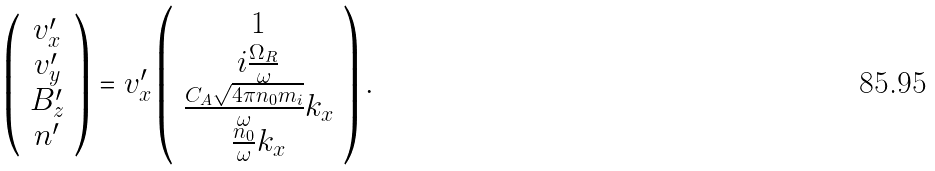Convert formula to latex. <formula><loc_0><loc_0><loc_500><loc_500>\left ( \begin{array} { c } v _ { x } ^ { \prime } \\ v _ { y } ^ { \prime } \\ B _ { z } ^ { \prime } \\ n ^ { \prime } \end{array} \right ) = v _ { x } ^ { \prime } \left ( \begin{array} { c } 1 \\ i \frac { \Omega _ { R } } { \omega } \\ \frac { C _ { A } \sqrt { 4 \pi n _ { 0 } m _ { i } } } { \omega } k _ { x } \\ \frac { n _ { 0 } } { \omega } k _ { x } \end{array} \right ) .</formula> 